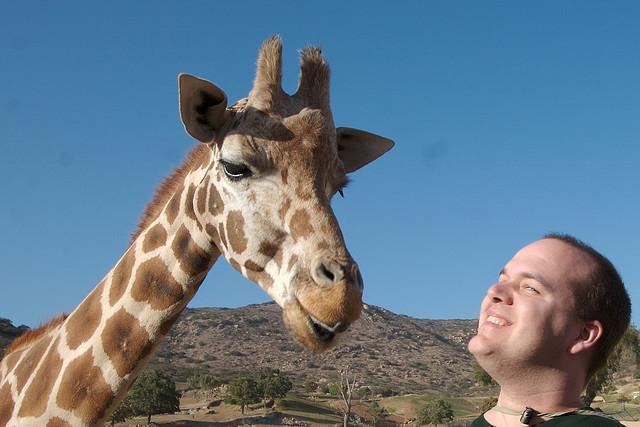How many clouds are in the sky?
Give a very brief answer. 0. 